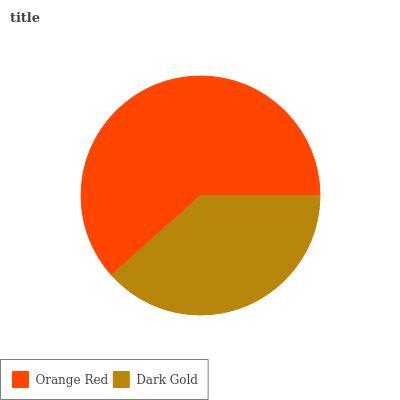Is Dark Gold the minimum?
Answer yes or no. Yes. Is Orange Red the maximum?
Answer yes or no. Yes. Is Dark Gold the maximum?
Answer yes or no. No. Is Orange Red greater than Dark Gold?
Answer yes or no. Yes. Is Dark Gold less than Orange Red?
Answer yes or no. Yes. Is Dark Gold greater than Orange Red?
Answer yes or no. No. Is Orange Red less than Dark Gold?
Answer yes or no. No. Is Orange Red the high median?
Answer yes or no. Yes. Is Dark Gold the low median?
Answer yes or no. Yes. Is Dark Gold the high median?
Answer yes or no. No. Is Orange Red the low median?
Answer yes or no. No. 